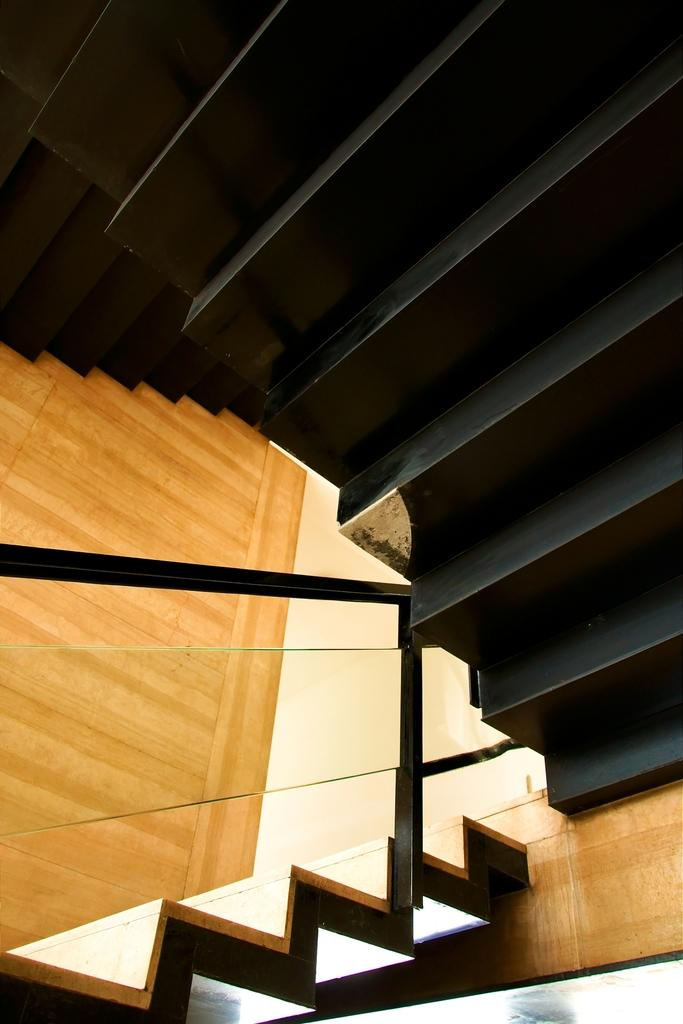What type of structure can be seen in the image? There are stairs in the image. To which building do the stairs belong? The stairs belong to a building. What type of discussion is taking place between the baby and the flowers in the image? There is no baby or flowers present in the image; it only features stairs belonging to a building. 